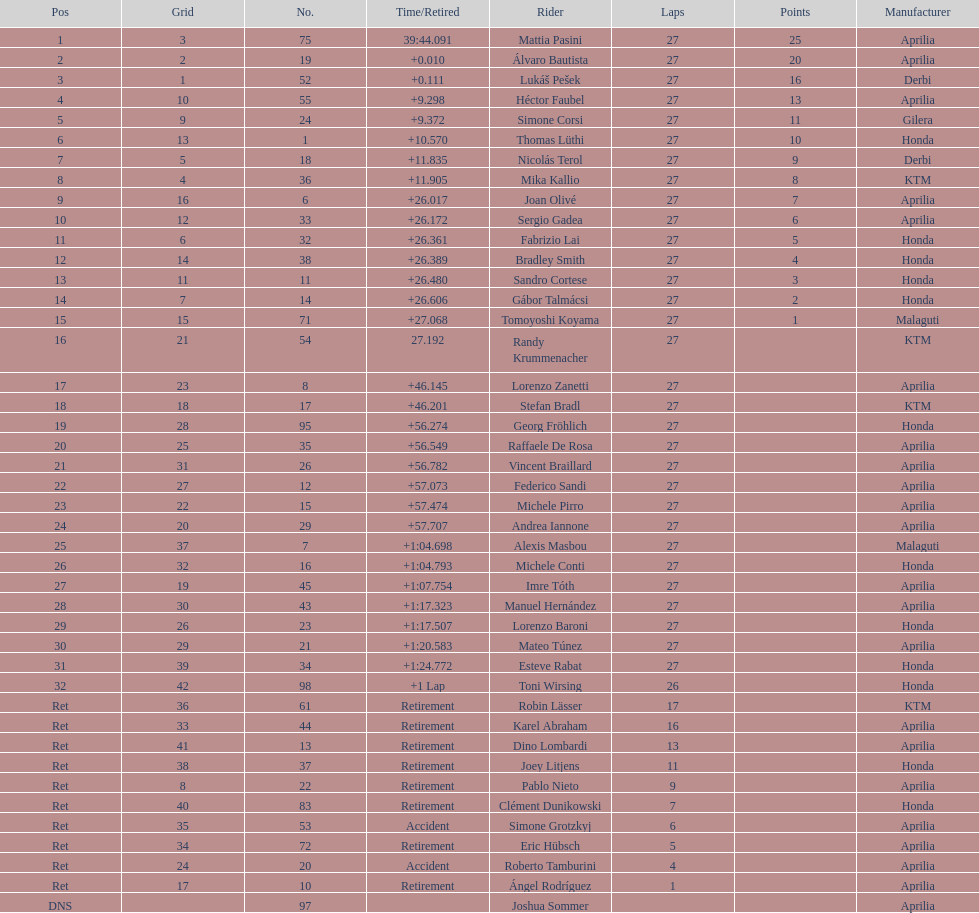Can you give me this table as a dict? {'header': ['Pos', 'Grid', 'No.', 'Time/Retired', 'Rider', 'Laps', 'Points', 'Manufacturer'], 'rows': [['1', '3', '75', '39:44.091', 'Mattia Pasini', '27', '25', 'Aprilia'], ['2', '2', '19', '+0.010', 'Álvaro Bautista', '27', '20', 'Aprilia'], ['3', '1', '52', '+0.111', 'Lukáš Pešek', '27', '16', 'Derbi'], ['4', '10', '55', '+9.298', 'Héctor Faubel', '27', '13', 'Aprilia'], ['5', '9', '24', '+9.372', 'Simone Corsi', '27', '11', 'Gilera'], ['6', '13', '1', '+10.570', 'Thomas Lüthi', '27', '10', 'Honda'], ['7', '5', '18', '+11.835', 'Nicolás Terol', '27', '9', 'Derbi'], ['8', '4', '36', '+11.905', 'Mika Kallio', '27', '8', 'KTM'], ['9', '16', '6', '+26.017', 'Joan Olivé', '27', '7', 'Aprilia'], ['10', '12', '33', '+26.172', 'Sergio Gadea', '27', '6', 'Aprilia'], ['11', '6', '32', '+26.361', 'Fabrizio Lai', '27', '5', 'Honda'], ['12', '14', '38', '+26.389', 'Bradley Smith', '27', '4', 'Honda'], ['13', '11', '11', '+26.480', 'Sandro Cortese', '27', '3', 'Honda'], ['14', '7', '14', '+26.606', 'Gábor Talmácsi', '27', '2', 'Honda'], ['15', '15', '71', '+27.068', 'Tomoyoshi Koyama', '27', '1', 'Malaguti'], ['16', '21', '54', '27.192', 'Randy Krummenacher', '27', '', 'KTM'], ['17', '23', '8', '+46.145', 'Lorenzo Zanetti', '27', '', 'Aprilia'], ['18', '18', '17', '+46.201', 'Stefan Bradl', '27', '', 'KTM'], ['19', '28', '95', '+56.274', 'Georg Fröhlich', '27', '', 'Honda'], ['20', '25', '35', '+56.549', 'Raffaele De Rosa', '27', '', 'Aprilia'], ['21', '31', '26', '+56.782', 'Vincent Braillard', '27', '', 'Aprilia'], ['22', '27', '12', '+57.073', 'Federico Sandi', '27', '', 'Aprilia'], ['23', '22', '15', '+57.474', 'Michele Pirro', '27', '', 'Aprilia'], ['24', '20', '29', '+57.707', 'Andrea Iannone', '27', '', 'Aprilia'], ['25', '37', '7', '+1:04.698', 'Alexis Masbou', '27', '', 'Malaguti'], ['26', '32', '16', '+1:04.793', 'Michele Conti', '27', '', 'Honda'], ['27', '19', '45', '+1:07.754', 'Imre Tóth', '27', '', 'Aprilia'], ['28', '30', '43', '+1:17.323', 'Manuel Hernández', '27', '', 'Aprilia'], ['29', '26', '23', '+1:17.507', 'Lorenzo Baroni', '27', '', 'Honda'], ['30', '29', '21', '+1:20.583', 'Mateo Túnez', '27', '', 'Aprilia'], ['31', '39', '34', '+1:24.772', 'Esteve Rabat', '27', '', 'Honda'], ['32', '42', '98', '+1 Lap', 'Toni Wirsing', '26', '', 'Honda'], ['Ret', '36', '61', 'Retirement', 'Robin Lässer', '17', '', 'KTM'], ['Ret', '33', '44', 'Retirement', 'Karel Abraham', '16', '', 'Aprilia'], ['Ret', '41', '13', 'Retirement', 'Dino Lombardi', '13', '', 'Aprilia'], ['Ret', '38', '37', 'Retirement', 'Joey Litjens', '11', '', 'Honda'], ['Ret', '8', '22', 'Retirement', 'Pablo Nieto', '9', '', 'Aprilia'], ['Ret', '40', '83', 'Retirement', 'Clément Dunikowski', '7', '', 'Honda'], ['Ret', '35', '53', 'Accident', 'Simone Grotzkyj', '6', '', 'Aprilia'], ['Ret', '34', '72', 'Retirement', 'Eric Hübsch', '5', '', 'Aprilia'], ['Ret', '24', '20', 'Accident', 'Roberto Tamburini', '4', '', 'Aprilia'], ['Ret', '17', '10', 'Retirement', 'Ángel Rodríguez', '1', '', 'Aprilia'], ['DNS', '', '97', '', 'Joshua Sommer', '', '', 'Aprilia']]} How many german racers finished the race? 4. 